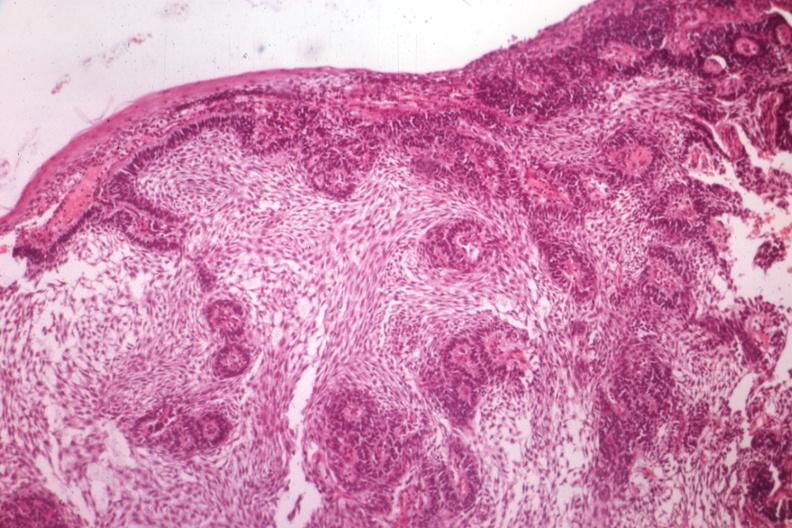s bone, mandible present?
Answer the question using a single word or phrase. Yes 